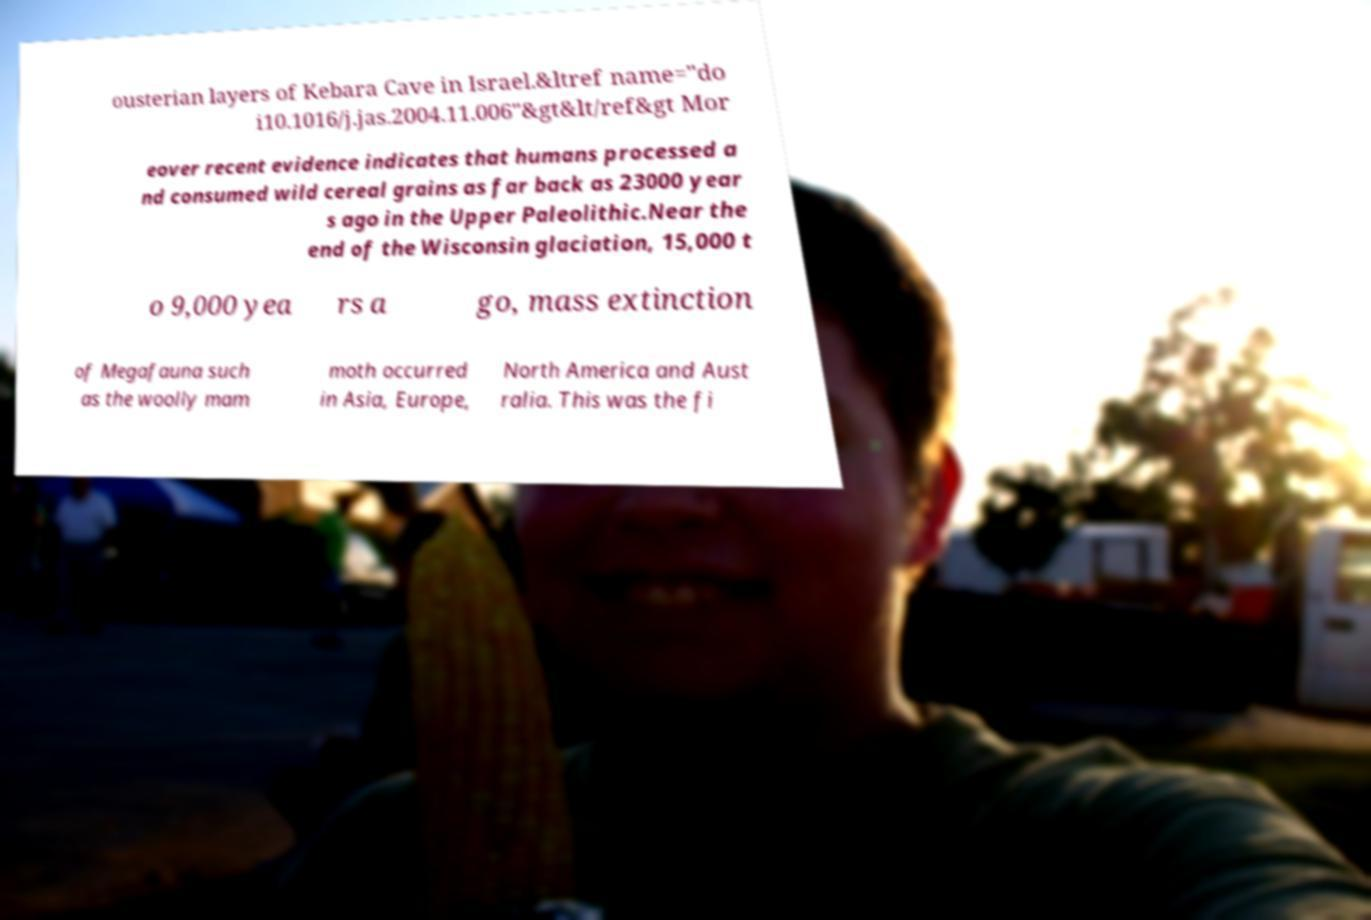What messages or text are displayed in this image? I need them in a readable, typed format. ousterian layers of Kebara Cave in Israel.&ltref name="do i10.1016/j.jas.2004.11.006"&gt&lt/ref&gt Mor eover recent evidence indicates that humans processed a nd consumed wild cereal grains as far back as 23000 year s ago in the Upper Paleolithic.Near the end of the Wisconsin glaciation, 15,000 t o 9,000 yea rs a go, mass extinction of Megafauna such as the woolly mam moth occurred in Asia, Europe, North America and Aust ralia. This was the fi 